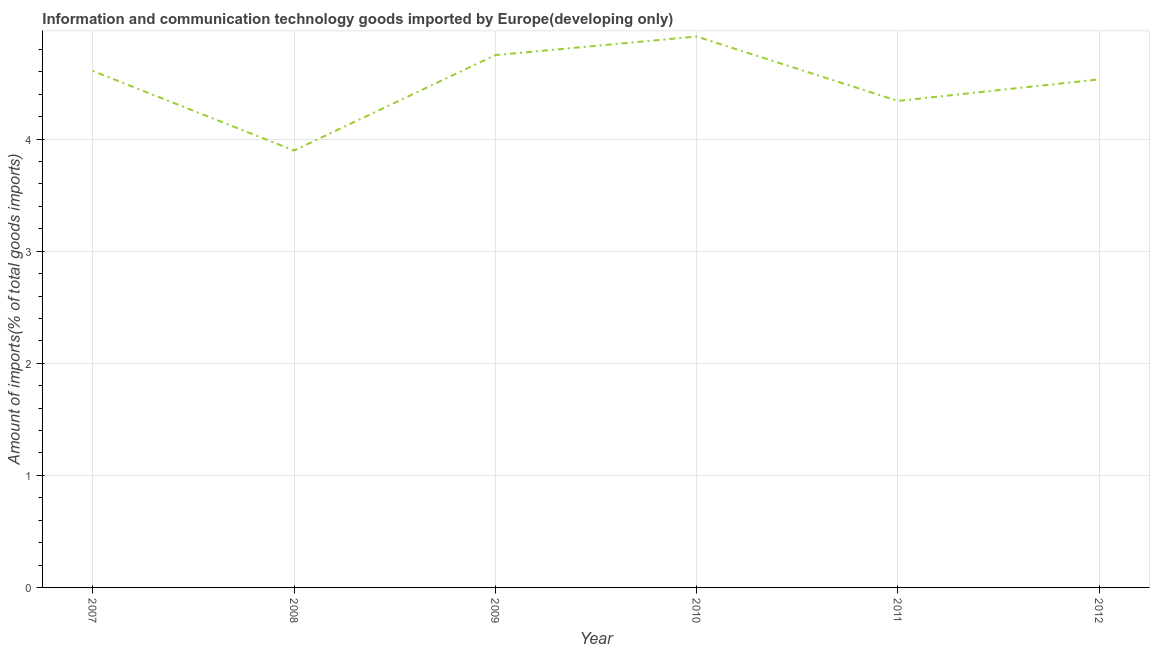What is the amount of ict goods imports in 2007?
Make the answer very short. 4.61. Across all years, what is the maximum amount of ict goods imports?
Ensure brevity in your answer.  4.92. Across all years, what is the minimum amount of ict goods imports?
Keep it short and to the point. 3.9. In which year was the amount of ict goods imports minimum?
Provide a short and direct response. 2008. What is the sum of the amount of ict goods imports?
Your answer should be compact. 27.04. What is the difference between the amount of ict goods imports in 2007 and 2012?
Provide a succinct answer. 0.08. What is the average amount of ict goods imports per year?
Give a very brief answer. 4.51. What is the median amount of ict goods imports?
Provide a short and direct response. 4.57. What is the ratio of the amount of ict goods imports in 2010 to that in 2011?
Provide a succinct answer. 1.13. Is the amount of ict goods imports in 2009 less than that in 2010?
Offer a terse response. Yes. Is the difference between the amount of ict goods imports in 2010 and 2012 greater than the difference between any two years?
Your answer should be very brief. No. What is the difference between the highest and the second highest amount of ict goods imports?
Ensure brevity in your answer.  0.17. What is the difference between the highest and the lowest amount of ict goods imports?
Your answer should be compact. 1.02. In how many years, is the amount of ict goods imports greater than the average amount of ict goods imports taken over all years?
Your answer should be very brief. 4. How many lines are there?
Offer a very short reply. 1. How many years are there in the graph?
Your answer should be very brief. 6. What is the difference between two consecutive major ticks on the Y-axis?
Offer a very short reply. 1. Are the values on the major ticks of Y-axis written in scientific E-notation?
Your answer should be compact. No. What is the title of the graph?
Ensure brevity in your answer.  Information and communication technology goods imported by Europe(developing only). What is the label or title of the X-axis?
Keep it short and to the point. Year. What is the label or title of the Y-axis?
Provide a succinct answer. Amount of imports(% of total goods imports). What is the Amount of imports(% of total goods imports) of 2007?
Offer a terse response. 4.61. What is the Amount of imports(% of total goods imports) of 2008?
Offer a terse response. 3.9. What is the Amount of imports(% of total goods imports) in 2009?
Provide a short and direct response. 4.75. What is the Amount of imports(% of total goods imports) of 2010?
Offer a terse response. 4.92. What is the Amount of imports(% of total goods imports) of 2011?
Your answer should be very brief. 4.34. What is the Amount of imports(% of total goods imports) in 2012?
Ensure brevity in your answer.  4.53. What is the difference between the Amount of imports(% of total goods imports) in 2007 and 2008?
Your answer should be compact. 0.71. What is the difference between the Amount of imports(% of total goods imports) in 2007 and 2009?
Your answer should be compact. -0.14. What is the difference between the Amount of imports(% of total goods imports) in 2007 and 2010?
Your answer should be compact. -0.31. What is the difference between the Amount of imports(% of total goods imports) in 2007 and 2011?
Offer a terse response. 0.27. What is the difference between the Amount of imports(% of total goods imports) in 2007 and 2012?
Keep it short and to the point. 0.08. What is the difference between the Amount of imports(% of total goods imports) in 2008 and 2009?
Give a very brief answer. -0.85. What is the difference between the Amount of imports(% of total goods imports) in 2008 and 2010?
Provide a short and direct response. -1.02. What is the difference between the Amount of imports(% of total goods imports) in 2008 and 2011?
Your response must be concise. -0.44. What is the difference between the Amount of imports(% of total goods imports) in 2008 and 2012?
Provide a short and direct response. -0.63. What is the difference between the Amount of imports(% of total goods imports) in 2009 and 2010?
Your response must be concise. -0.17. What is the difference between the Amount of imports(% of total goods imports) in 2009 and 2011?
Your answer should be compact. 0.41. What is the difference between the Amount of imports(% of total goods imports) in 2009 and 2012?
Your response must be concise. 0.22. What is the difference between the Amount of imports(% of total goods imports) in 2010 and 2011?
Your answer should be very brief. 0.57. What is the difference between the Amount of imports(% of total goods imports) in 2010 and 2012?
Your response must be concise. 0.38. What is the difference between the Amount of imports(% of total goods imports) in 2011 and 2012?
Keep it short and to the point. -0.19. What is the ratio of the Amount of imports(% of total goods imports) in 2007 to that in 2008?
Offer a very short reply. 1.18. What is the ratio of the Amount of imports(% of total goods imports) in 2007 to that in 2009?
Offer a terse response. 0.97. What is the ratio of the Amount of imports(% of total goods imports) in 2007 to that in 2010?
Keep it short and to the point. 0.94. What is the ratio of the Amount of imports(% of total goods imports) in 2007 to that in 2011?
Keep it short and to the point. 1.06. What is the ratio of the Amount of imports(% of total goods imports) in 2007 to that in 2012?
Your response must be concise. 1.02. What is the ratio of the Amount of imports(% of total goods imports) in 2008 to that in 2009?
Your answer should be very brief. 0.82. What is the ratio of the Amount of imports(% of total goods imports) in 2008 to that in 2010?
Your answer should be very brief. 0.79. What is the ratio of the Amount of imports(% of total goods imports) in 2008 to that in 2011?
Give a very brief answer. 0.9. What is the ratio of the Amount of imports(% of total goods imports) in 2008 to that in 2012?
Provide a succinct answer. 0.86. What is the ratio of the Amount of imports(% of total goods imports) in 2009 to that in 2010?
Offer a terse response. 0.97. What is the ratio of the Amount of imports(% of total goods imports) in 2009 to that in 2011?
Your answer should be very brief. 1.09. What is the ratio of the Amount of imports(% of total goods imports) in 2009 to that in 2012?
Your response must be concise. 1.05. What is the ratio of the Amount of imports(% of total goods imports) in 2010 to that in 2011?
Offer a terse response. 1.13. What is the ratio of the Amount of imports(% of total goods imports) in 2010 to that in 2012?
Your response must be concise. 1.08. What is the ratio of the Amount of imports(% of total goods imports) in 2011 to that in 2012?
Ensure brevity in your answer.  0.96. 